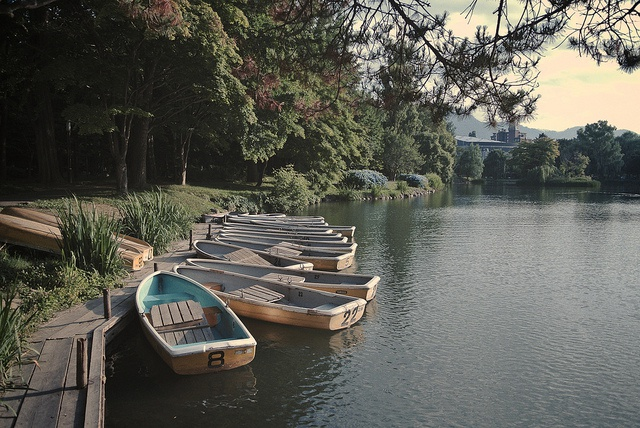Describe the objects in this image and their specific colors. I can see boat in black, gray, darkgray, and teal tones, boat in black, gray, darkgray, and maroon tones, boat in black, gray, darkgray, and maroon tones, boat in black, tan, and gray tones, and boat in black, gray, darkgray, and maroon tones in this image. 